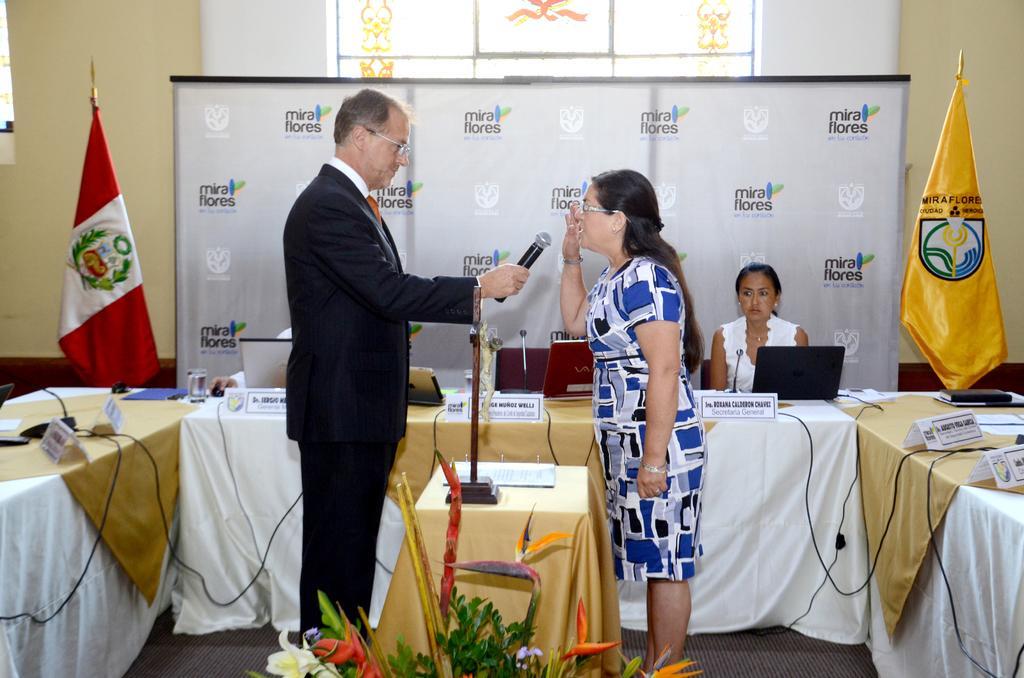How would you summarize this image in a sentence or two? The man in the middle of the picture wearing black blazer is holding a microphone in his hand. In front of him, we see a woman in white and blue dress is talking on the microphone. In between them, we see a table on which stand and papers are placed. Behind that, we see a table on which name tags, cables, book, water glass, microphone, papers, laptop are placed. Behind that, we see the woman in white dress is sitting on the chair and beside her, we see a yellow flag. Behind her, we see a white banner and window. On the left corner of the picture, we see a flag which is in red and white color. 